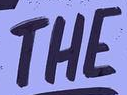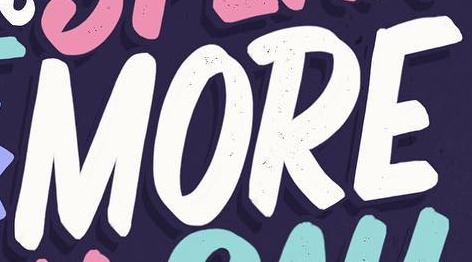Identify the words shown in these images in order, separated by a semicolon. THE; MORE 